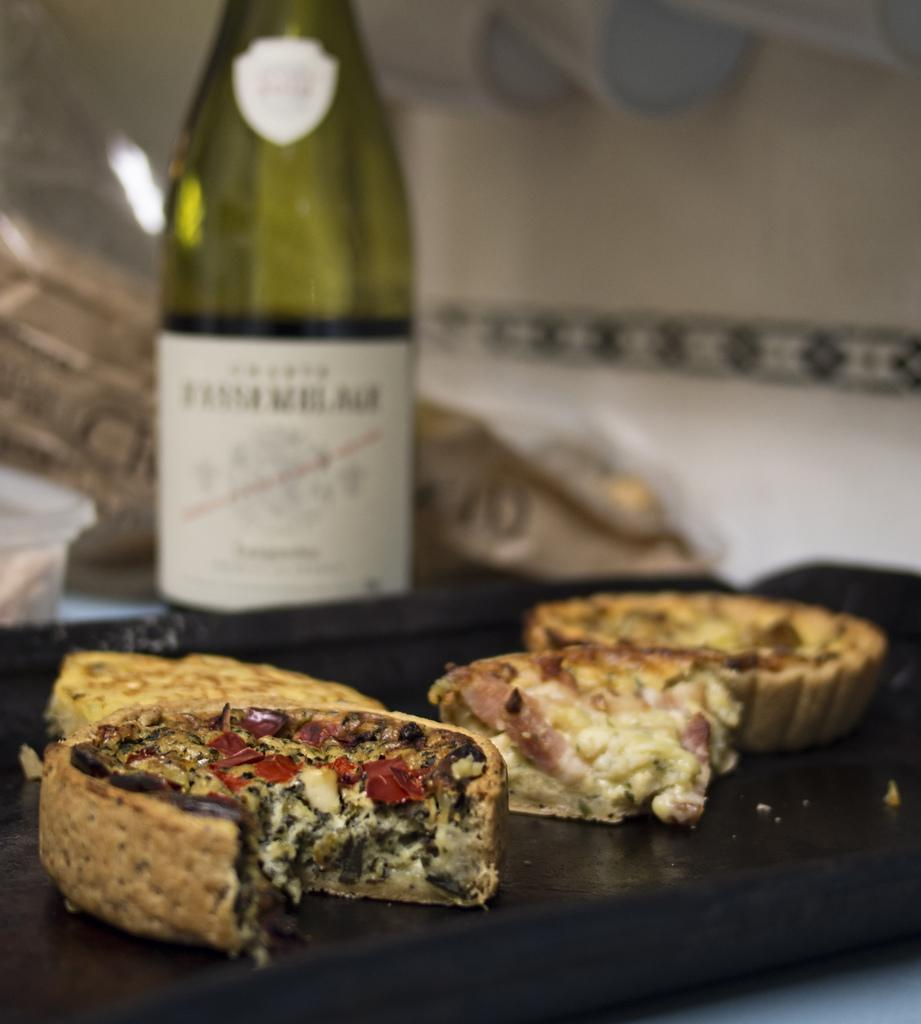What is present in the image related to food? There are food items in the image. How are the food items arranged or contained? The food items are in a tray. What else can be seen in the background of the image? There is a bottle in the background of the image. Can you see any jellyfish swimming in the food items in the image? There are no jellyfish present in the image, as it features food items in a tray and a bottle in the background. What time of day is it in the image, considering the presence of the afternoon? The facts provided do not mention the time of day or the presence of an afternoon, so it cannot be determined from the image. 